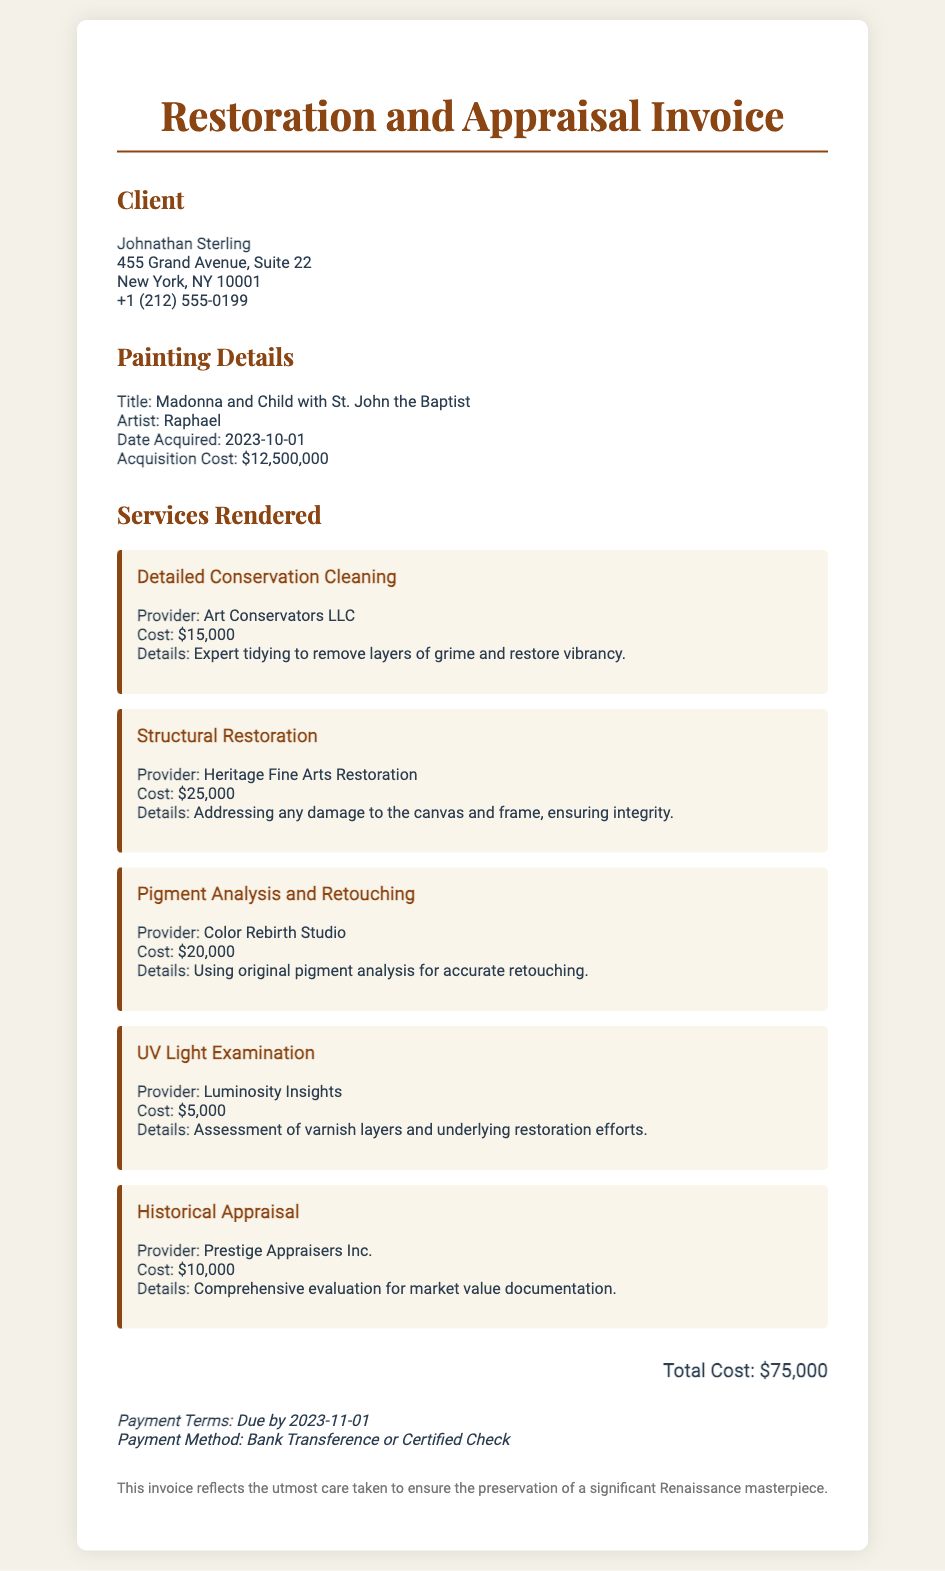What is the title of the painting? The title of the painting is mentioned in the painting details section of the document.
Answer: Madonna and Child with St. John the Baptist Who is the artist of the painting? The artist's name is provided in the painting details section of the document.
Answer: Raphael What was the acquisition cost of the painting? The acquisition cost is specified in the painting details of the document.
Answer: $12,500,000 What is the total cost of services rendered for restoration? The total cost is calculated based on the sum of all individual service costs listed in the document.
Answer: $75,000 When is the payment due? The payment due date is noted in the payment terms section of the document.
Answer: 2023-11-01 Which company provided the detailed conservation cleaning service? The provider's name for this particular service is outlined in the services rendered section.
Answer: Art Conservators LLC How much was charged for historical appraisal? The cost for the historical appraisal is detailed in the services rendered section.
Answer: $10,000 What type of examination was performed for UV light assessment? The kind of examination is indicated in the service description for UV light assessment.
Answer: UV Light Examination What is the payment method mentioned in the invoice? The document specifies the accepted payment methods in the payment terms section.
Answer: Bank Transference or Certified Check 